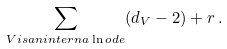Convert formula to latex. <formula><loc_0><loc_0><loc_500><loc_500>\sum _ { V i s a n i n t e r n a \ln o d e } ( d _ { V } - 2 ) + r \, .</formula> 